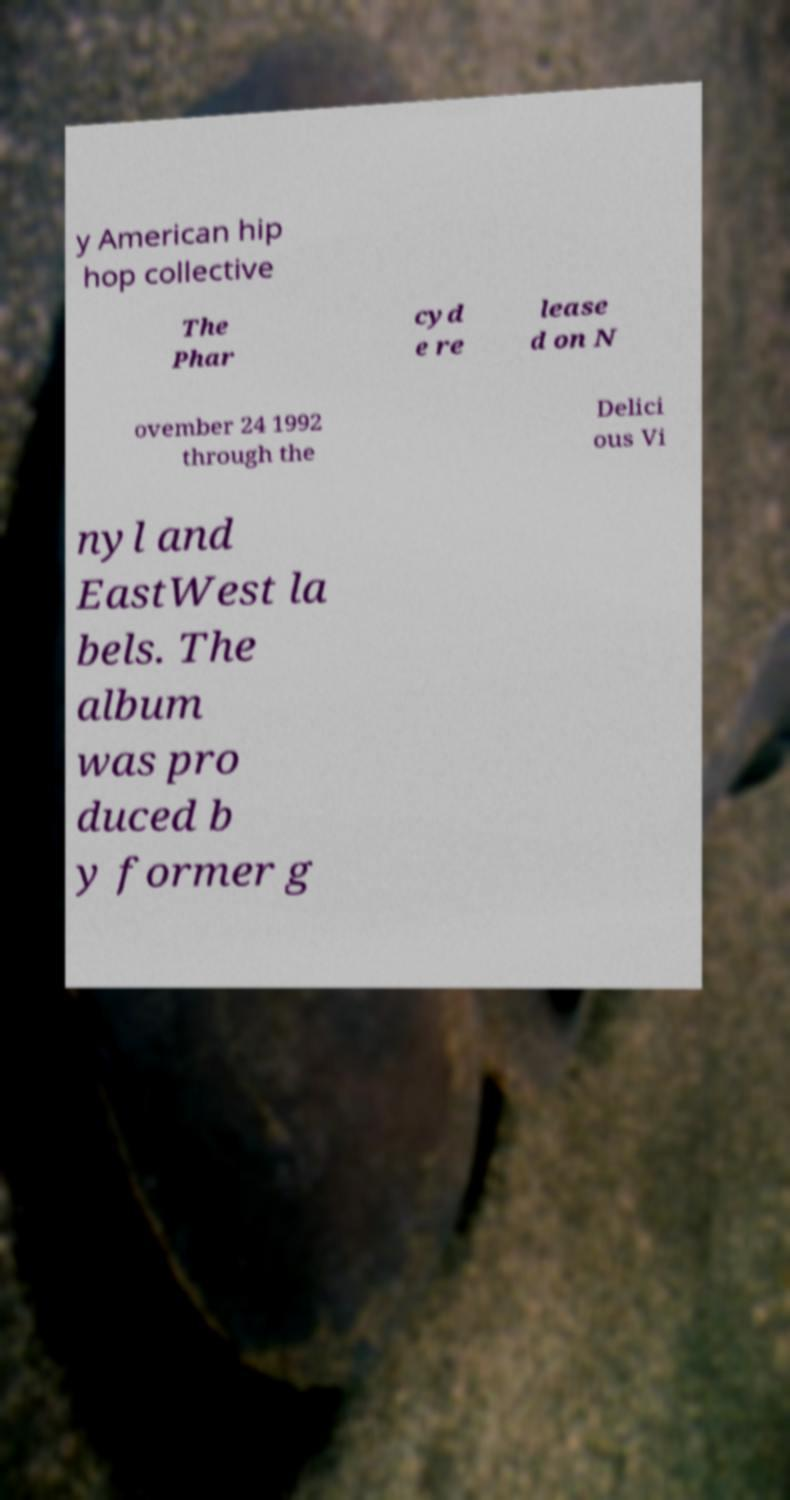What messages or text are displayed in this image? I need them in a readable, typed format. y American hip hop collective The Phar cyd e re lease d on N ovember 24 1992 through the Delici ous Vi nyl and EastWest la bels. The album was pro duced b y former g 